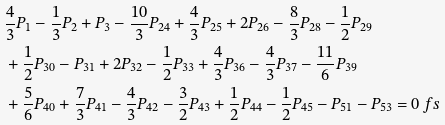Convert formula to latex. <formula><loc_0><loc_0><loc_500><loc_500>& \frac { 4 } { 3 } P _ { 1 } - \frac { 1 } { 3 } P _ { 2 } + P _ { 3 } - \frac { 1 0 } { 3 } P _ { 2 4 } + \frac { 4 } { 3 } P _ { 2 5 } + 2 P _ { 2 6 } - \frac { 8 } { 3 } P _ { 2 8 } - \frac { 1 } { 2 } P _ { 2 9 } \\ & + \frac { 1 } { 2 } P _ { 3 0 } - P _ { 3 1 } + 2 P _ { 3 2 } - \frac { 1 } { 2 } P _ { 3 3 } + \frac { 4 } { 3 } P _ { 3 6 } - \frac { 4 } { 3 } P _ { 3 7 } - \frac { 1 1 } { 6 } P _ { 3 9 } \\ & + \frac { 5 } { 6 } P _ { 4 0 } + \frac { 7 } { 3 } P _ { 4 1 } - \frac { 4 } { 3 } P _ { 4 2 } - \frac { 3 } { 2 } P _ { 4 3 } + \frac { 1 } { 2 } P _ { 4 4 } - \frac { 1 } { 2 } P _ { 4 5 } - P _ { 5 1 } - P _ { 5 3 } = 0 \ f s</formula> 